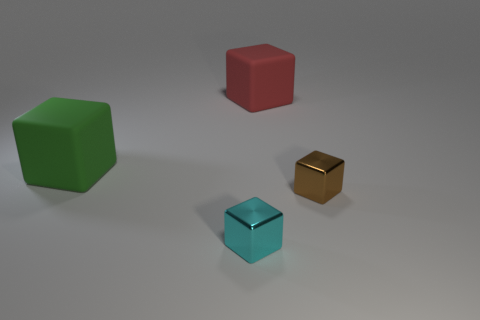Are there the same number of small cyan shiny things that are in front of the small brown shiny object and small cyan metal things behind the large red cube? After examining the image carefully, it appears that there is one small cyan shiny object in front of the small brown object, and there are no cyan objects behind the large red cube. Therefore, the answer is no, there are not the same number of small cyan shiny things in front of the small brown shiny object and small cyan metal things behind the large red cube. 